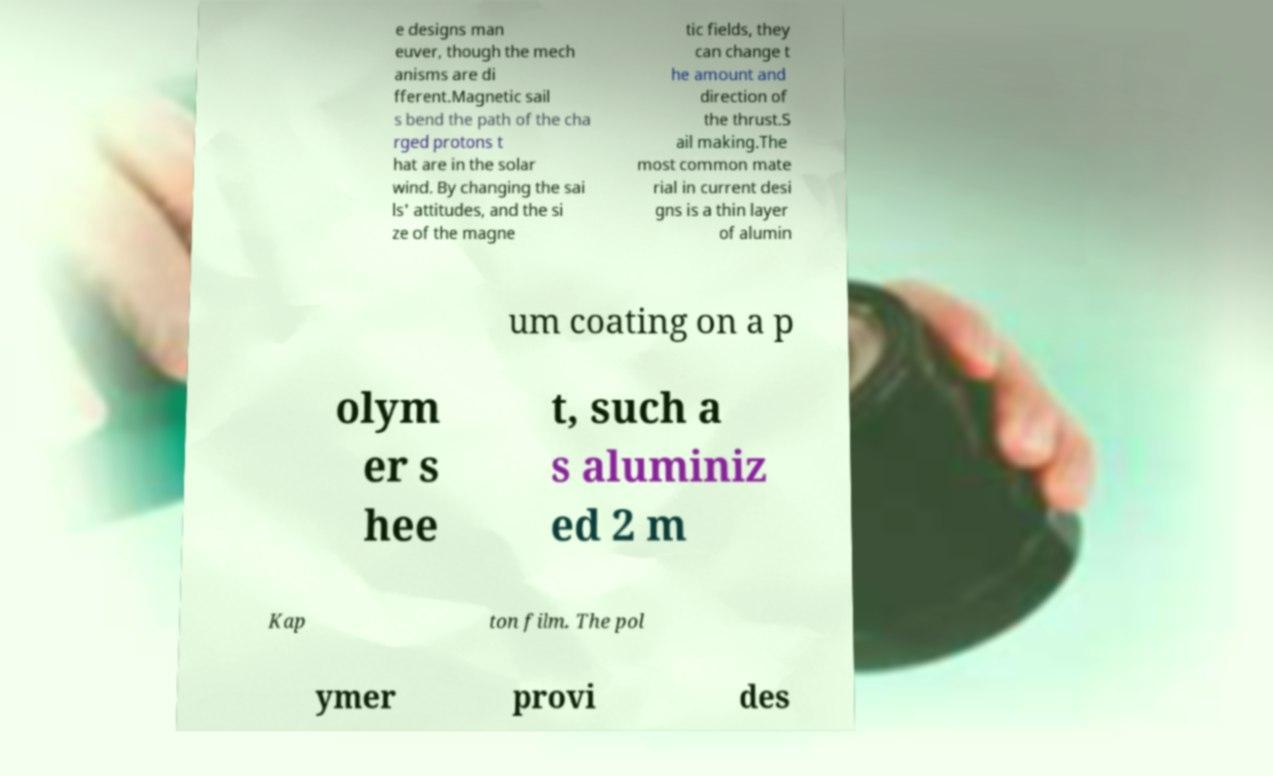Could you extract and type out the text from this image? e designs man euver, though the mech anisms are di fferent.Magnetic sail s bend the path of the cha rged protons t hat are in the solar wind. By changing the sai ls' attitudes, and the si ze of the magne tic fields, they can change t he amount and direction of the thrust.S ail making.The most common mate rial in current desi gns is a thin layer of alumin um coating on a p olym er s hee t, such a s aluminiz ed 2 m Kap ton film. The pol ymer provi des 